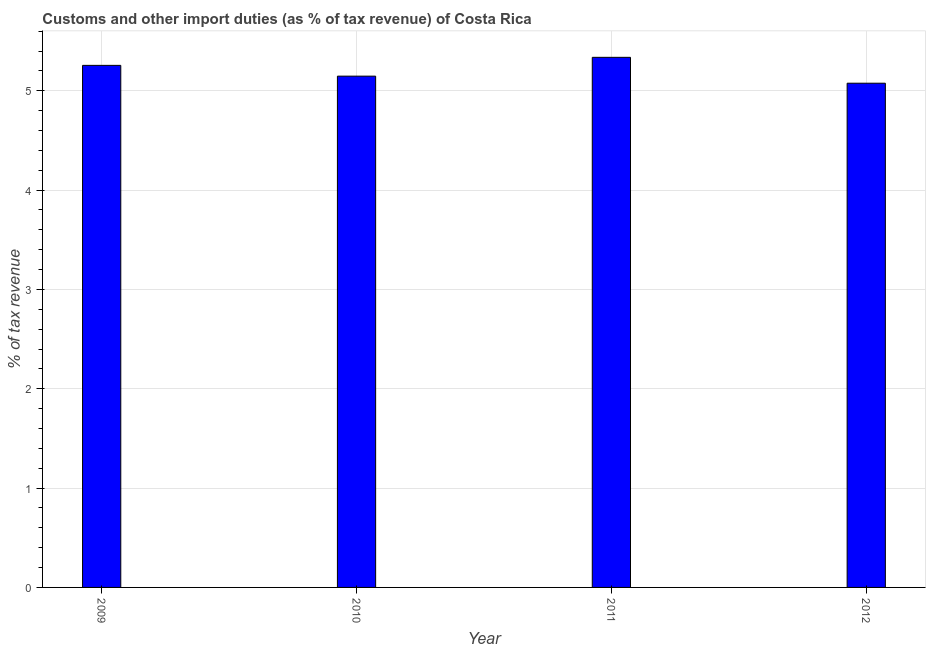Does the graph contain any zero values?
Provide a short and direct response. No. What is the title of the graph?
Provide a short and direct response. Customs and other import duties (as % of tax revenue) of Costa Rica. What is the label or title of the Y-axis?
Keep it short and to the point. % of tax revenue. What is the customs and other import duties in 2011?
Offer a very short reply. 5.34. Across all years, what is the maximum customs and other import duties?
Ensure brevity in your answer.  5.34. Across all years, what is the minimum customs and other import duties?
Your answer should be very brief. 5.08. In which year was the customs and other import duties maximum?
Provide a short and direct response. 2011. What is the sum of the customs and other import duties?
Provide a succinct answer. 20.81. What is the difference between the customs and other import duties in 2010 and 2012?
Make the answer very short. 0.07. What is the average customs and other import duties per year?
Your answer should be compact. 5.2. What is the median customs and other import duties?
Offer a terse response. 5.2. What is the ratio of the customs and other import duties in 2009 to that in 2011?
Provide a short and direct response. 0.98. Is the customs and other import duties in 2010 less than that in 2011?
Offer a terse response. Yes. What is the difference between the highest and the second highest customs and other import duties?
Provide a short and direct response. 0.08. Is the sum of the customs and other import duties in 2010 and 2012 greater than the maximum customs and other import duties across all years?
Provide a succinct answer. Yes. What is the difference between the highest and the lowest customs and other import duties?
Provide a succinct answer. 0.26. How many bars are there?
Provide a succinct answer. 4. How many years are there in the graph?
Your answer should be very brief. 4. What is the % of tax revenue of 2009?
Provide a short and direct response. 5.26. What is the % of tax revenue of 2010?
Your answer should be compact. 5.15. What is the % of tax revenue of 2011?
Keep it short and to the point. 5.34. What is the % of tax revenue of 2012?
Your answer should be compact. 5.08. What is the difference between the % of tax revenue in 2009 and 2010?
Provide a short and direct response. 0.11. What is the difference between the % of tax revenue in 2009 and 2011?
Your response must be concise. -0.08. What is the difference between the % of tax revenue in 2009 and 2012?
Keep it short and to the point. 0.18. What is the difference between the % of tax revenue in 2010 and 2011?
Your answer should be compact. -0.19. What is the difference between the % of tax revenue in 2010 and 2012?
Ensure brevity in your answer.  0.07. What is the difference between the % of tax revenue in 2011 and 2012?
Your answer should be compact. 0.26. What is the ratio of the % of tax revenue in 2009 to that in 2011?
Your answer should be very brief. 0.98. What is the ratio of the % of tax revenue in 2009 to that in 2012?
Your response must be concise. 1.03. What is the ratio of the % of tax revenue in 2010 to that in 2011?
Your answer should be very brief. 0.96. What is the ratio of the % of tax revenue in 2011 to that in 2012?
Your answer should be compact. 1.05. 